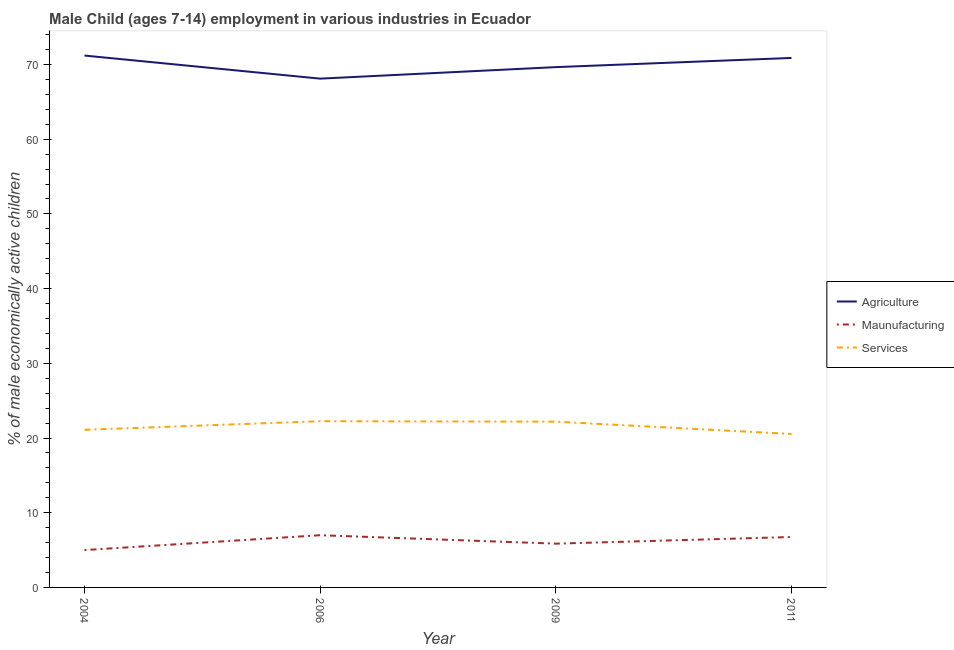How many different coloured lines are there?
Ensure brevity in your answer.  3. Is the number of lines equal to the number of legend labels?
Your response must be concise. Yes. What is the percentage of economically active children in agriculture in 2009?
Ensure brevity in your answer.  69.65. Across all years, what is the maximum percentage of economically active children in manufacturing?
Make the answer very short. 6.99. Across all years, what is the minimum percentage of economically active children in agriculture?
Ensure brevity in your answer.  68.11. In which year was the percentage of economically active children in agriculture maximum?
Provide a short and direct response. 2004. What is the total percentage of economically active children in agriculture in the graph?
Ensure brevity in your answer.  279.84. What is the difference between the percentage of economically active children in manufacturing in 2004 and that in 2006?
Provide a short and direct response. -1.99. What is the difference between the percentage of economically active children in agriculture in 2006 and the percentage of economically active children in services in 2004?
Your answer should be compact. 47.01. What is the average percentage of economically active children in services per year?
Provide a succinct answer. 21.52. What is the ratio of the percentage of economically active children in services in 2006 to that in 2009?
Provide a short and direct response. 1. What is the difference between the highest and the second highest percentage of economically active children in agriculture?
Provide a succinct answer. 0.32. What is the difference between the highest and the lowest percentage of economically active children in services?
Your answer should be compact. 1.71. In how many years, is the percentage of economically active children in agriculture greater than the average percentage of economically active children in agriculture taken over all years?
Give a very brief answer. 2. Is the sum of the percentage of economically active children in agriculture in 2004 and 2011 greater than the maximum percentage of economically active children in services across all years?
Provide a succinct answer. Yes. Does the percentage of economically active children in manufacturing monotonically increase over the years?
Provide a succinct answer. No. Is the percentage of economically active children in services strictly less than the percentage of economically active children in manufacturing over the years?
Your answer should be compact. No. How many years are there in the graph?
Keep it short and to the point. 4. Does the graph contain grids?
Your answer should be compact. No. Where does the legend appear in the graph?
Provide a succinct answer. Center right. What is the title of the graph?
Your answer should be very brief. Male Child (ages 7-14) employment in various industries in Ecuador. Does "Wage workers" appear as one of the legend labels in the graph?
Your answer should be compact. No. What is the label or title of the Y-axis?
Offer a very short reply. % of male economically active children. What is the % of male economically active children in Agriculture in 2004?
Your answer should be very brief. 71.2. What is the % of male economically active children in Services in 2004?
Your answer should be very brief. 21.1. What is the % of male economically active children of Agriculture in 2006?
Give a very brief answer. 68.11. What is the % of male economically active children in Maunufacturing in 2006?
Offer a very short reply. 6.99. What is the % of male economically active children in Services in 2006?
Make the answer very short. 22.25. What is the % of male economically active children in Agriculture in 2009?
Ensure brevity in your answer.  69.65. What is the % of male economically active children of Maunufacturing in 2009?
Provide a short and direct response. 5.86. What is the % of male economically active children of Services in 2009?
Make the answer very short. 22.19. What is the % of male economically active children in Agriculture in 2011?
Provide a short and direct response. 70.88. What is the % of male economically active children in Maunufacturing in 2011?
Offer a very short reply. 6.75. What is the % of male economically active children in Services in 2011?
Your answer should be compact. 20.54. Across all years, what is the maximum % of male economically active children of Agriculture?
Your answer should be compact. 71.2. Across all years, what is the maximum % of male economically active children of Maunufacturing?
Ensure brevity in your answer.  6.99. Across all years, what is the maximum % of male economically active children in Services?
Make the answer very short. 22.25. Across all years, what is the minimum % of male economically active children of Agriculture?
Ensure brevity in your answer.  68.11. Across all years, what is the minimum % of male economically active children of Services?
Provide a succinct answer. 20.54. What is the total % of male economically active children of Agriculture in the graph?
Make the answer very short. 279.84. What is the total % of male economically active children in Maunufacturing in the graph?
Keep it short and to the point. 24.6. What is the total % of male economically active children in Services in the graph?
Offer a very short reply. 86.08. What is the difference between the % of male economically active children of Agriculture in 2004 and that in 2006?
Offer a very short reply. 3.09. What is the difference between the % of male economically active children in Maunufacturing in 2004 and that in 2006?
Your answer should be very brief. -1.99. What is the difference between the % of male economically active children in Services in 2004 and that in 2006?
Your answer should be very brief. -1.15. What is the difference between the % of male economically active children in Agriculture in 2004 and that in 2009?
Offer a very short reply. 1.55. What is the difference between the % of male economically active children of Maunufacturing in 2004 and that in 2009?
Your answer should be compact. -0.86. What is the difference between the % of male economically active children of Services in 2004 and that in 2009?
Keep it short and to the point. -1.09. What is the difference between the % of male economically active children in Agriculture in 2004 and that in 2011?
Provide a short and direct response. 0.32. What is the difference between the % of male economically active children of Maunufacturing in 2004 and that in 2011?
Offer a very short reply. -1.75. What is the difference between the % of male economically active children of Services in 2004 and that in 2011?
Offer a very short reply. 0.56. What is the difference between the % of male economically active children in Agriculture in 2006 and that in 2009?
Make the answer very short. -1.54. What is the difference between the % of male economically active children of Maunufacturing in 2006 and that in 2009?
Provide a short and direct response. 1.13. What is the difference between the % of male economically active children in Agriculture in 2006 and that in 2011?
Offer a very short reply. -2.77. What is the difference between the % of male economically active children of Maunufacturing in 2006 and that in 2011?
Provide a succinct answer. 0.24. What is the difference between the % of male economically active children of Services in 2006 and that in 2011?
Keep it short and to the point. 1.71. What is the difference between the % of male economically active children in Agriculture in 2009 and that in 2011?
Provide a succinct answer. -1.23. What is the difference between the % of male economically active children in Maunufacturing in 2009 and that in 2011?
Make the answer very short. -0.89. What is the difference between the % of male economically active children of Services in 2009 and that in 2011?
Give a very brief answer. 1.65. What is the difference between the % of male economically active children in Agriculture in 2004 and the % of male economically active children in Maunufacturing in 2006?
Offer a very short reply. 64.21. What is the difference between the % of male economically active children in Agriculture in 2004 and the % of male economically active children in Services in 2006?
Provide a short and direct response. 48.95. What is the difference between the % of male economically active children in Maunufacturing in 2004 and the % of male economically active children in Services in 2006?
Keep it short and to the point. -17.25. What is the difference between the % of male economically active children of Agriculture in 2004 and the % of male economically active children of Maunufacturing in 2009?
Offer a terse response. 65.34. What is the difference between the % of male economically active children of Agriculture in 2004 and the % of male economically active children of Services in 2009?
Provide a succinct answer. 49.01. What is the difference between the % of male economically active children in Maunufacturing in 2004 and the % of male economically active children in Services in 2009?
Your answer should be very brief. -17.19. What is the difference between the % of male economically active children in Agriculture in 2004 and the % of male economically active children in Maunufacturing in 2011?
Keep it short and to the point. 64.45. What is the difference between the % of male economically active children of Agriculture in 2004 and the % of male economically active children of Services in 2011?
Make the answer very short. 50.66. What is the difference between the % of male economically active children of Maunufacturing in 2004 and the % of male economically active children of Services in 2011?
Your answer should be compact. -15.54. What is the difference between the % of male economically active children in Agriculture in 2006 and the % of male economically active children in Maunufacturing in 2009?
Provide a succinct answer. 62.25. What is the difference between the % of male economically active children in Agriculture in 2006 and the % of male economically active children in Services in 2009?
Make the answer very short. 45.92. What is the difference between the % of male economically active children of Maunufacturing in 2006 and the % of male economically active children of Services in 2009?
Give a very brief answer. -15.2. What is the difference between the % of male economically active children of Agriculture in 2006 and the % of male economically active children of Maunufacturing in 2011?
Ensure brevity in your answer.  61.36. What is the difference between the % of male economically active children of Agriculture in 2006 and the % of male economically active children of Services in 2011?
Your answer should be compact. 47.57. What is the difference between the % of male economically active children of Maunufacturing in 2006 and the % of male economically active children of Services in 2011?
Your answer should be very brief. -13.55. What is the difference between the % of male economically active children in Agriculture in 2009 and the % of male economically active children in Maunufacturing in 2011?
Provide a short and direct response. 62.9. What is the difference between the % of male economically active children in Agriculture in 2009 and the % of male economically active children in Services in 2011?
Offer a very short reply. 49.11. What is the difference between the % of male economically active children in Maunufacturing in 2009 and the % of male economically active children in Services in 2011?
Your answer should be compact. -14.68. What is the average % of male economically active children of Agriculture per year?
Provide a short and direct response. 69.96. What is the average % of male economically active children of Maunufacturing per year?
Give a very brief answer. 6.15. What is the average % of male economically active children in Services per year?
Provide a succinct answer. 21.52. In the year 2004, what is the difference between the % of male economically active children in Agriculture and % of male economically active children in Maunufacturing?
Keep it short and to the point. 66.2. In the year 2004, what is the difference between the % of male economically active children of Agriculture and % of male economically active children of Services?
Offer a very short reply. 50.1. In the year 2004, what is the difference between the % of male economically active children of Maunufacturing and % of male economically active children of Services?
Provide a succinct answer. -16.1. In the year 2006, what is the difference between the % of male economically active children of Agriculture and % of male economically active children of Maunufacturing?
Your answer should be compact. 61.12. In the year 2006, what is the difference between the % of male economically active children in Agriculture and % of male economically active children in Services?
Provide a short and direct response. 45.86. In the year 2006, what is the difference between the % of male economically active children in Maunufacturing and % of male economically active children in Services?
Offer a terse response. -15.26. In the year 2009, what is the difference between the % of male economically active children of Agriculture and % of male economically active children of Maunufacturing?
Keep it short and to the point. 63.79. In the year 2009, what is the difference between the % of male economically active children of Agriculture and % of male economically active children of Services?
Provide a succinct answer. 47.46. In the year 2009, what is the difference between the % of male economically active children of Maunufacturing and % of male economically active children of Services?
Your response must be concise. -16.33. In the year 2011, what is the difference between the % of male economically active children of Agriculture and % of male economically active children of Maunufacturing?
Offer a terse response. 64.13. In the year 2011, what is the difference between the % of male economically active children in Agriculture and % of male economically active children in Services?
Give a very brief answer. 50.34. In the year 2011, what is the difference between the % of male economically active children in Maunufacturing and % of male economically active children in Services?
Your answer should be compact. -13.79. What is the ratio of the % of male economically active children in Agriculture in 2004 to that in 2006?
Your answer should be compact. 1.05. What is the ratio of the % of male economically active children in Maunufacturing in 2004 to that in 2006?
Ensure brevity in your answer.  0.72. What is the ratio of the % of male economically active children of Services in 2004 to that in 2006?
Offer a very short reply. 0.95. What is the ratio of the % of male economically active children of Agriculture in 2004 to that in 2009?
Provide a short and direct response. 1.02. What is the ratio of the % of male economically active children in Maunufacturing in 2004 to that in 2009?
Offer a very short reply. 0.85. What is the ratio of the % of male economically active children of Services in 2004 to that in 2009?
Make the answer very short. 0.95. What is the ratio of the % of male economically active children in Maunufacturing in 2004 to that in 2011?
Give a very brief answer. 0.74. What is the ratio of the % of male economically active children of Services in 2004 to that in 2011?
Give a very brief answer. 1.03. What is the ratio of the % of male economically active children in Agriculture in 2006 to that in 2009?
Give a very brief answer. 0.98. What is the ratio of the % of male economically active children in Maunufacturing in 2006 to that in 2009?
Provide a succinct answer. 1.19. What is the ratio of the % of male economically active children of Agriculture in 2006 to that in 2011?
Your answer should be very brief. 0.96. What is the ratio of the % of male economically active children of Maunufacturing in 2006 to that in 2011?
Your answer should be compact. 1.04. What is the ratio of the % of male economically active children of Agriculture in 2009 to that in 2011?
Offer a terse response. 0.98. What is the ratio of the % of male economically active children in Maunufacturing in 2009 to that in 2011?
Your answer should be compact. 0.87. What is the ratio of the % of male economically active children in Services in 2009 to that in 2011?
Your answer should be very brief. 1.08. What is the difference between the highest and the second highest % of male economically active children in Agriculture?
Keep it short and to the point. 0.32. What is the difference between the highest and the second highest % of male economically active children in Maunufacturing?
Your answer should be very brief. 0.24. What is the difference between the highest and the lowest % of male economically active children of Agriculture?
Keep it short and to the point. 3.09. What is the difference between the highest and the lowest % of male economically active children of Maunufacturing?
Your answer should be very brief. 1.99. What is the difference between the highest and the lowest % of male economically active children of Services?
Your response must be concise. 1.71. 